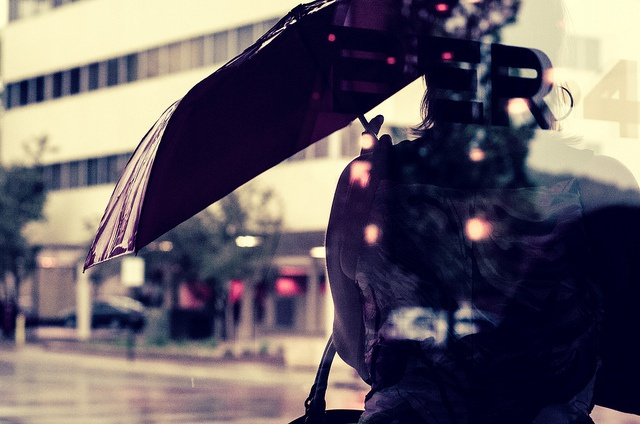Describe the objects in this image and their specific colors. I can see people in lightyellow, black, navy, gray, and tan tones, umbrella in lightyellow, black, tan, navy, and purple tones, car in lightyellow, navy, darkgray, and gray tones, and handbag in lightyellow, black, tan, and navy tones in this image. 